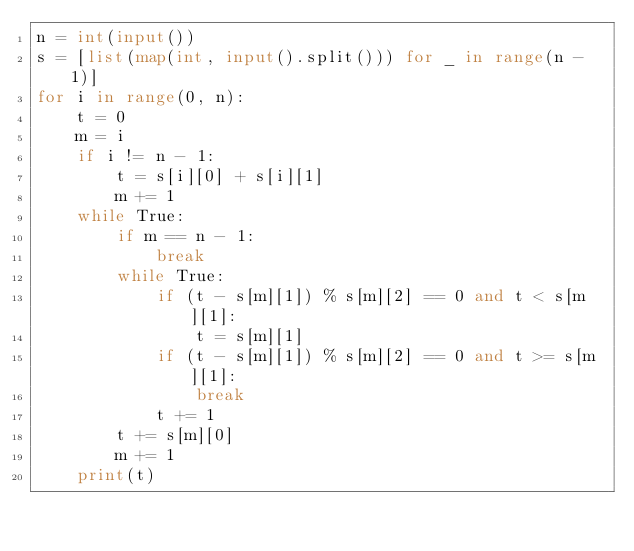<code> <loc_0><loc_0><loc_500><loc_500><_Python_>n = int(input())
s = [list(map(int, input().split())) for _ in range(n - 1)]
for i in range(0, n):
    t = 0
    m = i
    if i != n - 1:
        t = s[i][0] + s[i][1]
        m += 1
    while True:
        if m == n - 1:
            break
        while True:
            if (t - s[m][1]) % s[m][2] == 0 and t < s[m][1]:
                t = s[m][1]
            if (t - s[m][1]) % s[m][2] == 0 and t >= s[m][1]:
                break
            t += 1
        t += s[m][0]
        m += 1
    print(t)</code> 